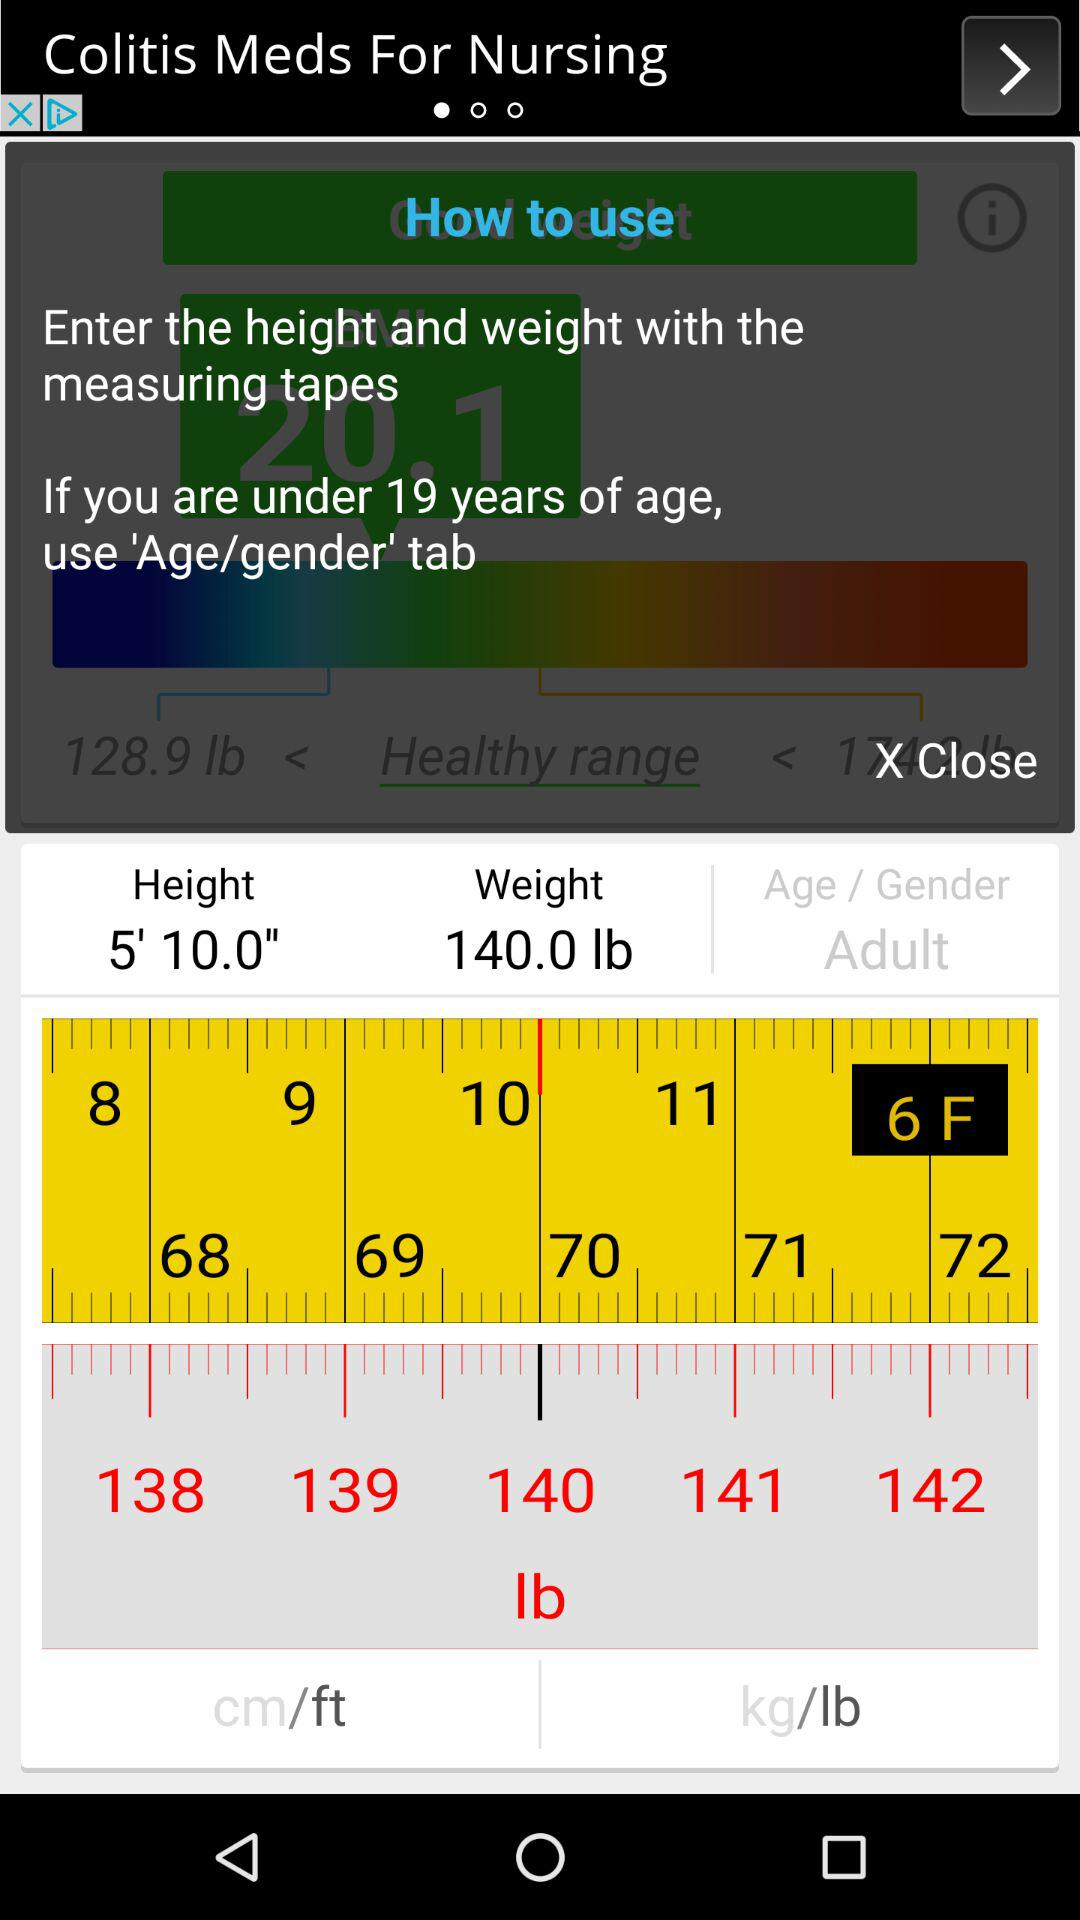What is the weight? The weight is 140 lbs. 